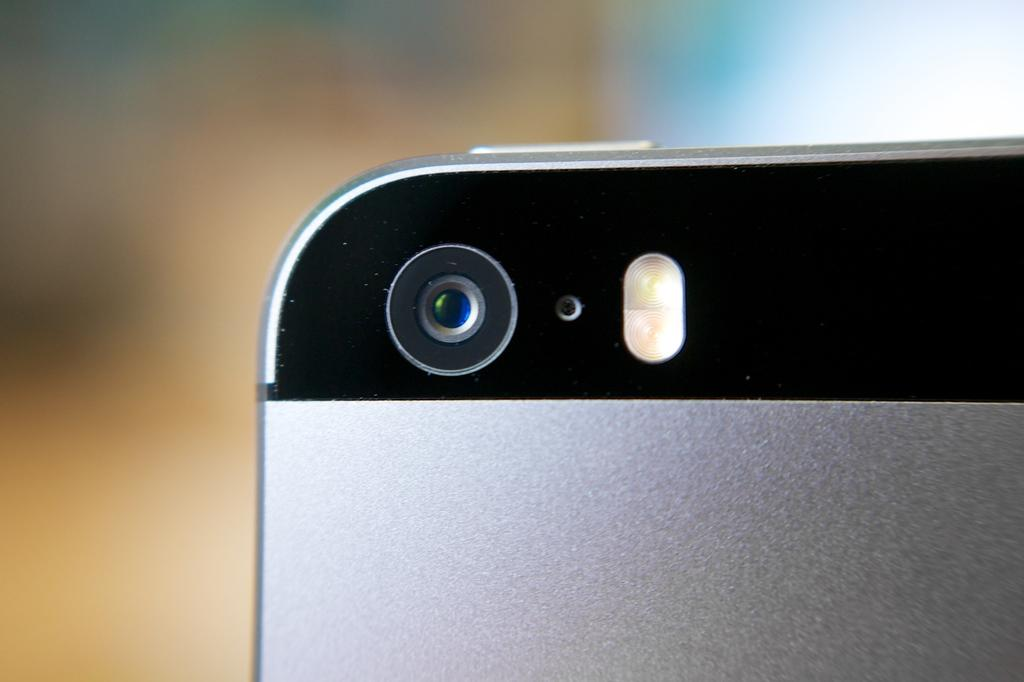What object is the main focus of the image? There is a camera of a mobile in the image. Can you describe the background of the image? The background of the image is blurred. What type of suit is hanging in the background of the image? There is no suit present in the image; the background is blurred. What brand of soap is visible in the image? There is no soap present in the image; the main focus is the camera of a mobile. 